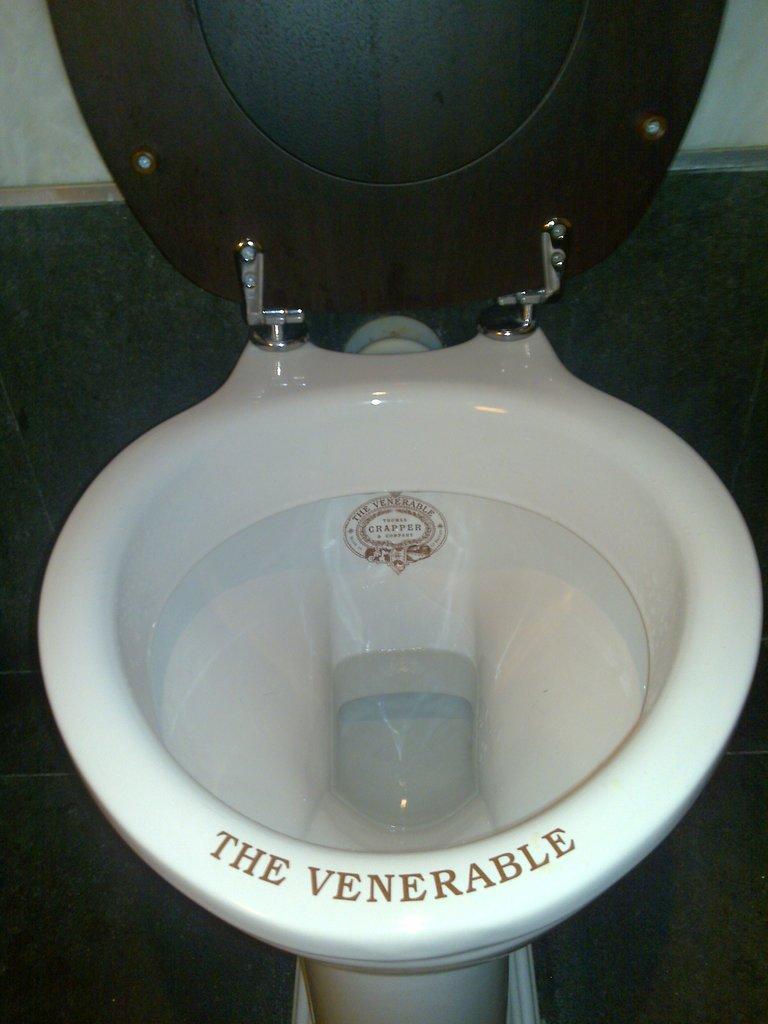What is the name of this toilet?
Your response must be concise. The venerable. What does the stamp say in the middle?
Your response must be concise. Crapper. 